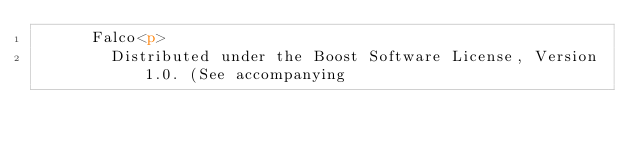<code> <loc_0><loc_0><loc_500><loc_500><_HTML_>      Falco<p>
        Distributed under the Boost Software License, Version 1.0. (See accompanying</code> 